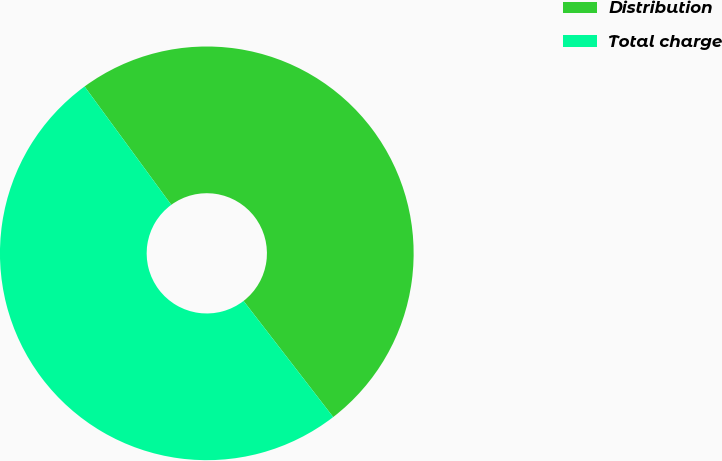Convert chart to OTSL. <chart><loc_0><loc_0><loc_500><loc_500><pie_chart><fcel>Distribution<fcel>Total charge<nl><fcel>49.6%<fcel>50.4%<nl></chart> 